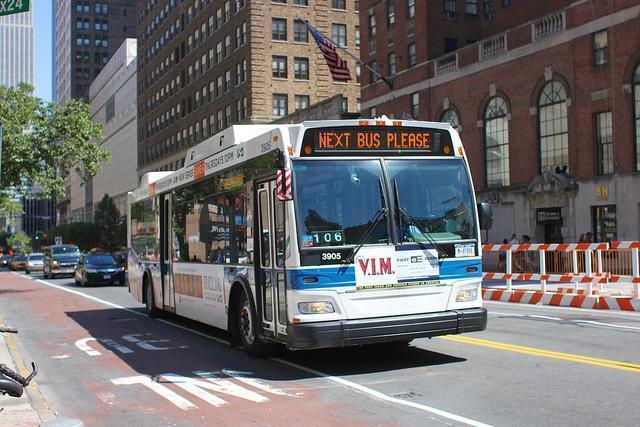Where does the bus go next?
Pick the right solution, then justify: 'Answer: answer
Rationale: rationale.'
Options: Bus stop, bus terminal, downtown, uptown. Answer: bus terminal.
Rationale: The bus is headed to the bus terminal since the sign says to take the next bus. 